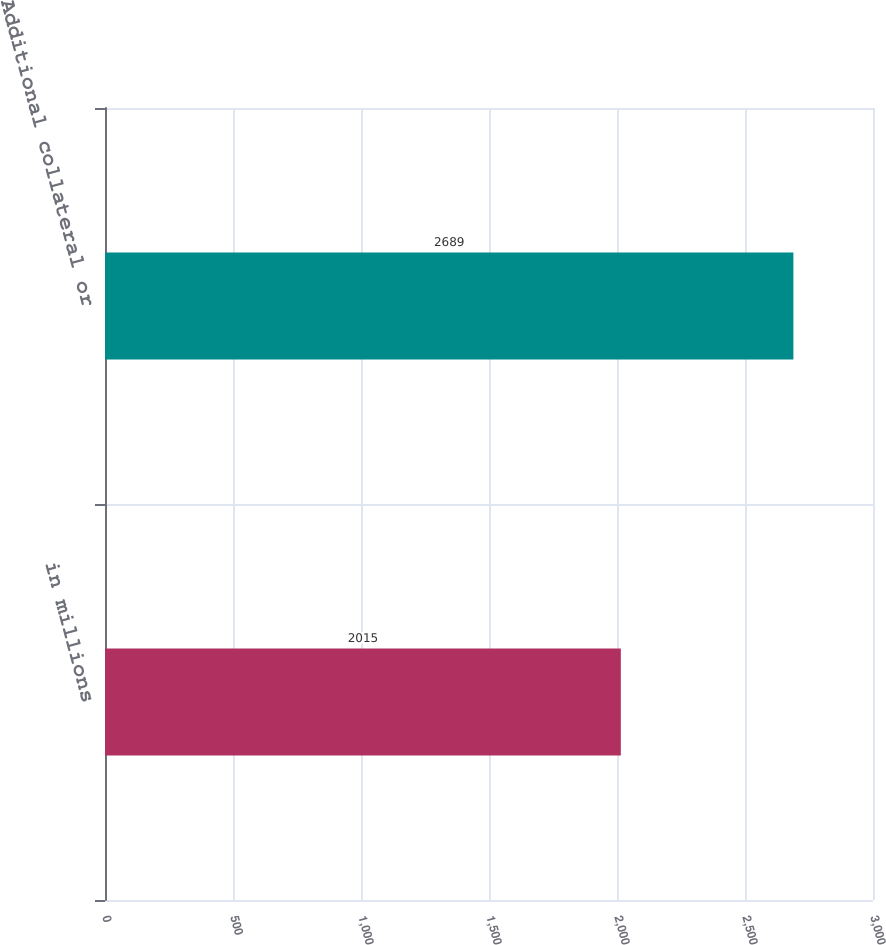Convert chart to OTSL. <chart><loc_0><loc_0><loc_500><loc_500><bar_chart><fcel>in millions<fcel>Additional collateral or<nl><fcel>2015<fcel>2689<nl></chart> 